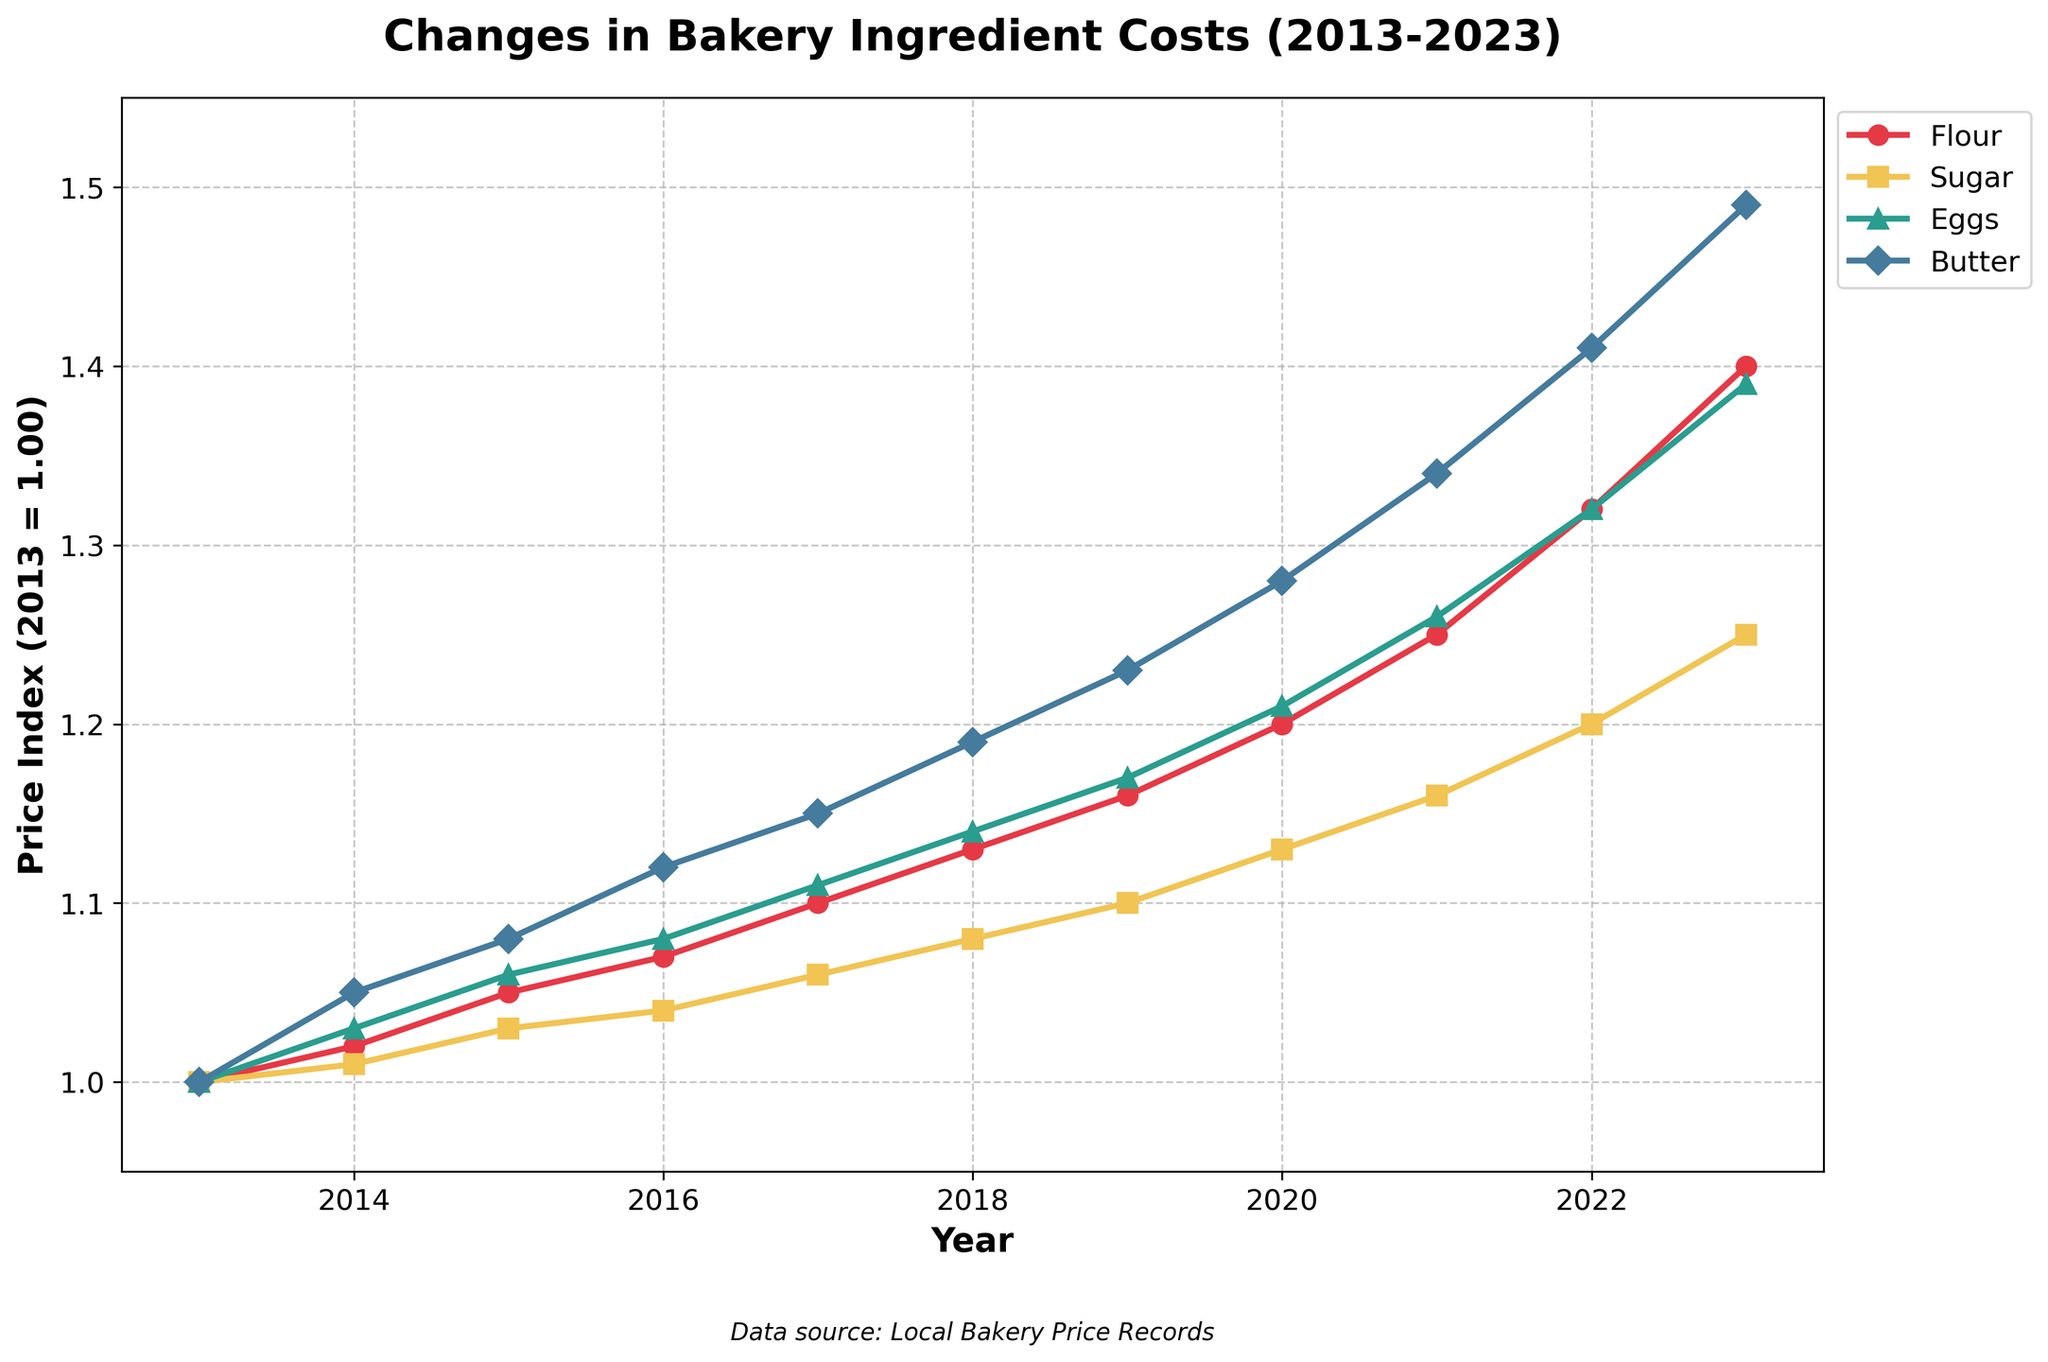what is the percentage increase in the cost of flour from 2013 to 2023? To find the percentage increase, we use the formula: \((\frac{{\text{{Price in 2023}} - \text{{Price in 2013}}}}{\text{{Price in 2013}}}) \times 100\). For flour, the price in 2023 is 1.40, and the price in 2013 is 1.00. So, the calculation is \((\frac{1.40 - 1.00}{1.00}) \times 100 = 40\%\)
Answer: 40% which ingredient had the highest relative price increase over the period from 2013 to 2023? To determine which ingredient had the highest relative price increase, we calculate the percentage increase for each ingredient using the same formula as above. Flour: 40%, Sugar: 25%, Eggs: 39%, Butter: 49%. The highest is Butter with a 49% increase
Answer: Butter in what year did the cost of eggs surpass 1.20? Referring to the plot, the cost of eggs surpassed 1.20 in the year 2020
Answer: 2020 how do the price trends of flour and sugar compare between 2017 and 2020? From 2017 to 2020, the cost of flour increased from 1.10 to 1.20, a difference of 0.10. In the same period, the cost of sugar increased from 1.06 to 1.13, a difference of 0.07. Thus, the price of flour increased more than the price of sugar over these years
Answer: Flour increased more than Sugar which ingredient had the least price change from 2014 to 2021, and what was the change? We calculate the difference for each ingredient between 2014 and 2021. Flour: \(1.25 - 1.02 = 0.23\), Sugar: \(1.16 - 1.01 = 0.15\), Eggs: \(1.26 - 1.03 = 0.23\), Butter: \(1.34 - 1.05 = 0.29\). Sugar had the least price change with an increase of 0.15
Answer: Sugar, 0.15 describe the overall trend for butter costs from 2013 to 2023 Referring to the figure, Butter costs steadily increase every year from 1.00 in 2013 to 1.49 in 2023, showing a consistent upward trend
Answer: Consistent upward trend by what factor did the cost of sugar multiply from 2013 to 2023? The factor is calculated by dividing the cost in 2023 by the cost in 2013. For sugar, the cost in 2023 is 1.25, and in 2013 it was 1.00. So, \( \frac{1.25}{1.00} = 1.25 \)
Answer: 1.25 which year saw the steepest increase in flour cost compared to the previous year? To find this, we look for the largest year-over-year increase. From the data: 2017 to 2018 (1.13 - 1.10 = 0.03), 2018 to 2019 (1.16 - 1.13 = 0.03), 2019 to 2020 (1.20 - 1.16 = 0.04), 2020 to 2021 (1.25 - 1.20 = 0.05), 2021 to 2022 (1.32 - 1.25 = 0.07), 2022 to 2023 (1.40 - 1.32 = 0.08). The steepest increase in cost occurred from 2022 to 2023
Answer: 2022 